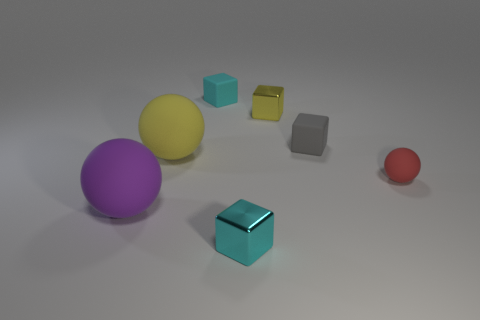Subtract all yellow balls. How many cyan blocks are left? 2 Subtract all big balls. How many balls are left? 1 Add 2 purple spheres. How many objects exist? 9 Subtract 1 balls. How many balls are left? 2 Subtract all gray blocks. How many blocks are left? 3 Subtract all spheres. How many objects are left? 4 Add 3 gray matte objects. How many gray matte objects are left? 4 Add 6 red balls. How many red balls exist? 7 Subtract 0 red cylinders. How many objects are left? 7 Subtract all blue balls. Subtract all gray cylinders. How many balls are left? 3 